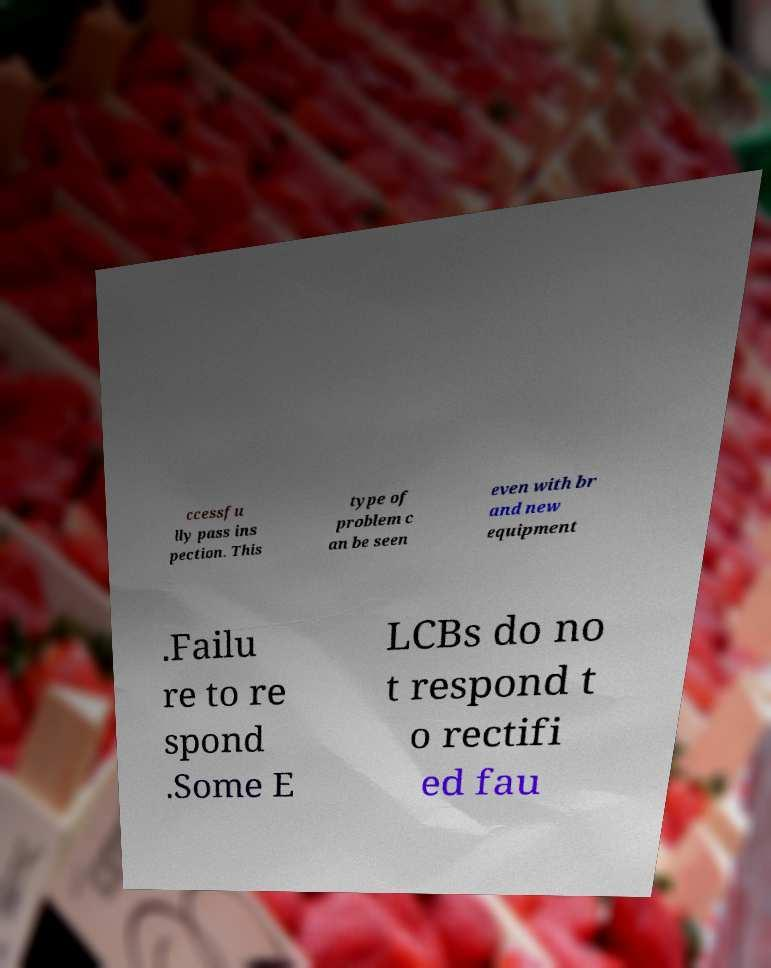Could you extract and type out the text from this image? ccessfu lly pass ins pection. This type of problem c an be seen even with br and new equipment .Failu re to re spond .Some E LCBs do no t respond t o rectifi ed fau 